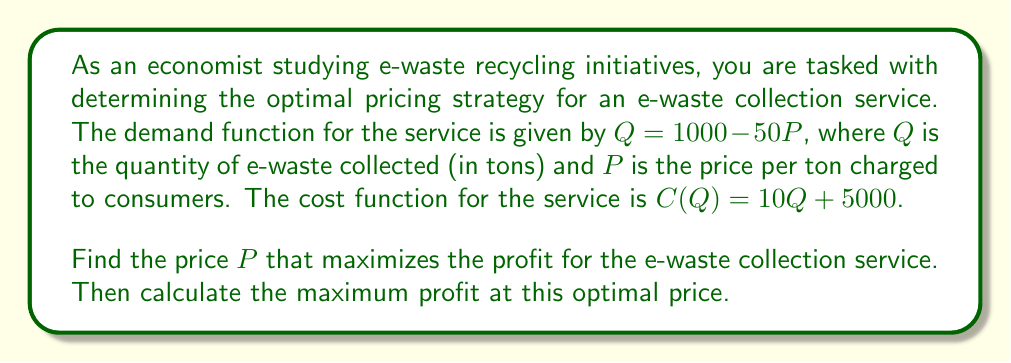Give your solution to this math problem. To solve this problem, we'll follow these steps:

1) First, express the profit function in terms of P:
   Profit = Revenue - Cost
   $\pi(P) = PQ - C(Q)$
   $\pi(P) = P(1000 - 50P) - [10(1000 - 50P) + 5000]$
   $\pi(P) = 1000P - 50P^2 - 10000 + 500P - 5000$
   $\pi(P) = -50P^2 + 1500P - 15000$

2) To find the maximum profit, we need to find where the derivative of the profit function equals zero:
   $\frac{d\pi}{dP} = -100P + 1500$
   Set this equal to zero:
   $-100P + 1500 = 0$
   $-100P = -1500$
   $P = 15$

3) To confirm this is a maximum, we can check the second derivative:
   $\frac{d^2\pi}{dP^2} = -100$, which is negative, confirming a maximum.

4) Now that we have the optimal price, we can calculate the maximum profit:
   $\pi(15) = -50(15)^2 + 1500(15) - 15000$
   $= -50(225) + 22500 - 15000$
   $= -11250 + 22500 - 15000$
   $= -3750 + 22500$
   $= 18750$

Therefore, the optimal price is $15 per ton, and the maximum profit at this price is $18,750.
Answer: The optimal price is $P = $15 per ton, and the maximum profit is $18,750. 